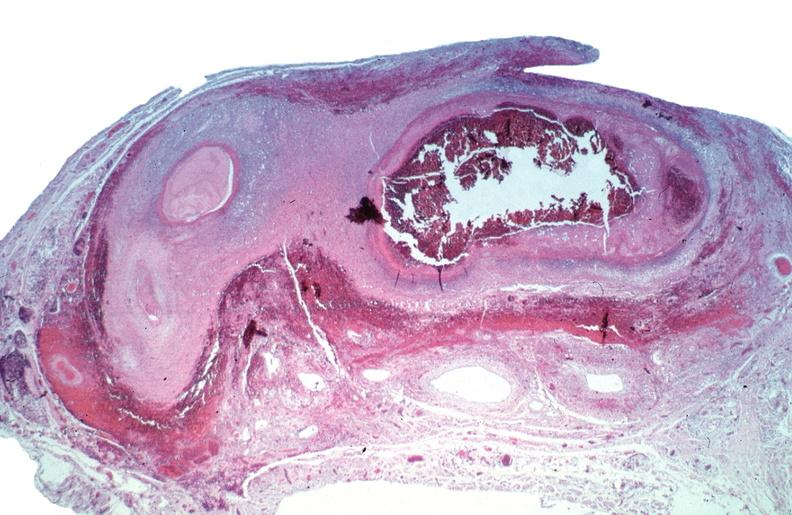s vasculature present?
Answer the question using a single word or phrase. Yes 